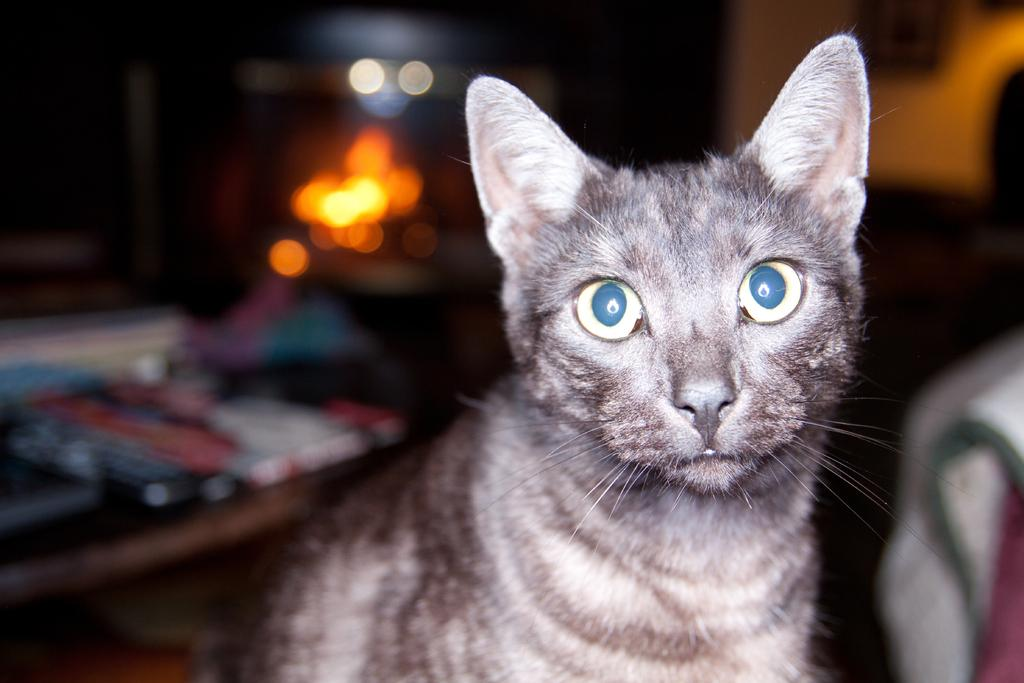What type of animal is in the image? There is a cat in the image. Can you describe the background of the image? There are blurred things behind the cat in the image. What type of silverware is visible in the image? There is no silverware present in the image; it only features a cat and a blurred background. 